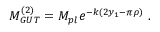<formula> <loc_0><loc_0><loc_500><loc_500>M _ { G U T } ^ { ( 2 ) } = M _ { p l } e ^ { - k ( 2 y _ { 1 } - \pi \rho ) } . \,</formula> 